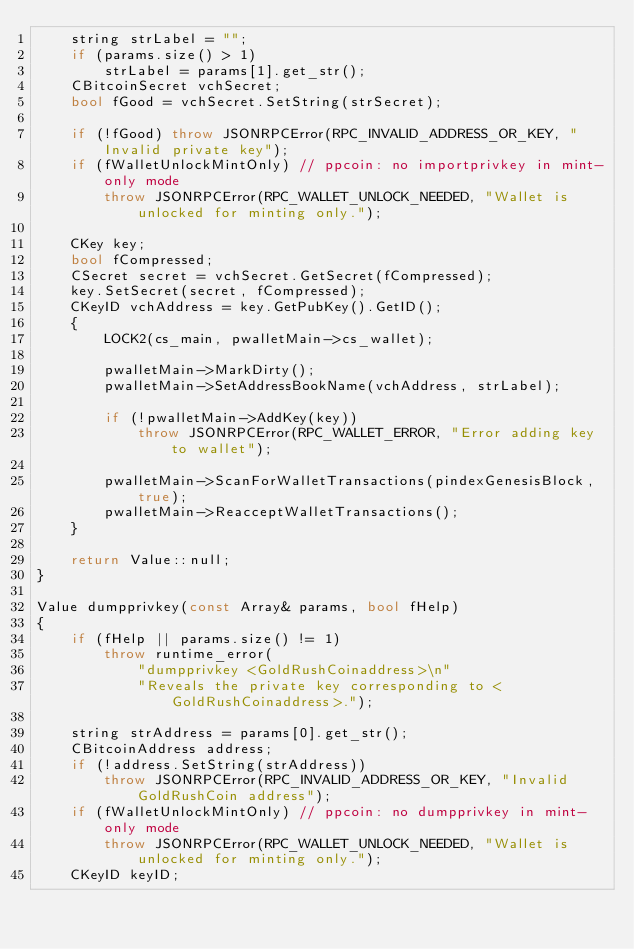Convert code to text. <code><loc_0><loc_0><loc_500><loc_500><_C++_>    string strLabel = "";
    if (params.size() > 1)
        strLabel = params[1].get_str();
    CBitcoinSecret vchSecret;
    bool fGood = vchSecret.SetString(strSecret);

    if (!fGood) throw JSONRPCError(RPC_INVALID_ADDRESS_OR_KEY, "Invalid private key");
    if (fWalletUnlockMintOnly) // ppcoin: no importprivkey in mint-only mode
        throw JSONRPCError(RPC_WALLET_UNLOCK_NEEDED, "Wallet is unlocked for minting only.");

    CKey key;
    bool fCompressed;
    CSecret secret = vchSecret.GetSecret(fCompressed);
    key.SetSecret(secret, fCompressed);
    CKeyID vchAddress = key.GetPubKey().GetID();
    {
        LOCK2(cs_main, pwalletMain->cs_wallet);

        pwalletMain->MarkDirty();
        pwalletMain->SetAddressBookName(vchAddress, strLabel);

        if (!pwalletMain->AddKey(key))
            throw JSONRPCError(RPC_WALLET_ERROR, "Error adding key to wallet");

        pwalletMain->ScanForWalletTransactions(pindexGenesisBlock, true);
        pwalletMain->ReacceptWalletTransactions();
    }

    return Value::null;
}

Value dumpprivkey(const Array& params, bool fHelp)
{
    if (fHelp || params.size() != 1)
        throw runtime_error(
            "dumpprivkey <GoldRushCoinaddress>\n"
            "Reveals the private key corresponding to <GoldRushCoinaddress>.");

    string strAddress = params[0].get_str();
    CBitcoinAddress address;
    if (!address.SetString(strAddress))
        throw JSONRPCError(RPC_INVALID_ADDRESS_OR_KEY, "Invalid GoldRushCoin address");
    if (fWalletUnlockMintOnly) // ppcoin: no dumpprivkey in mint-only mode
        throw JSONRPCError(RPC_WALLET_UNLOCK_NEEDED, "Wallet is unlocked for minting only.");
    CKeyID keyID;</code> 